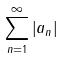<formula> <loc_0><loc_0><loc_500><loc_500>\sum _ { n = 1 } ^ { \infty } \left | a _ { n } \right |</formula> 